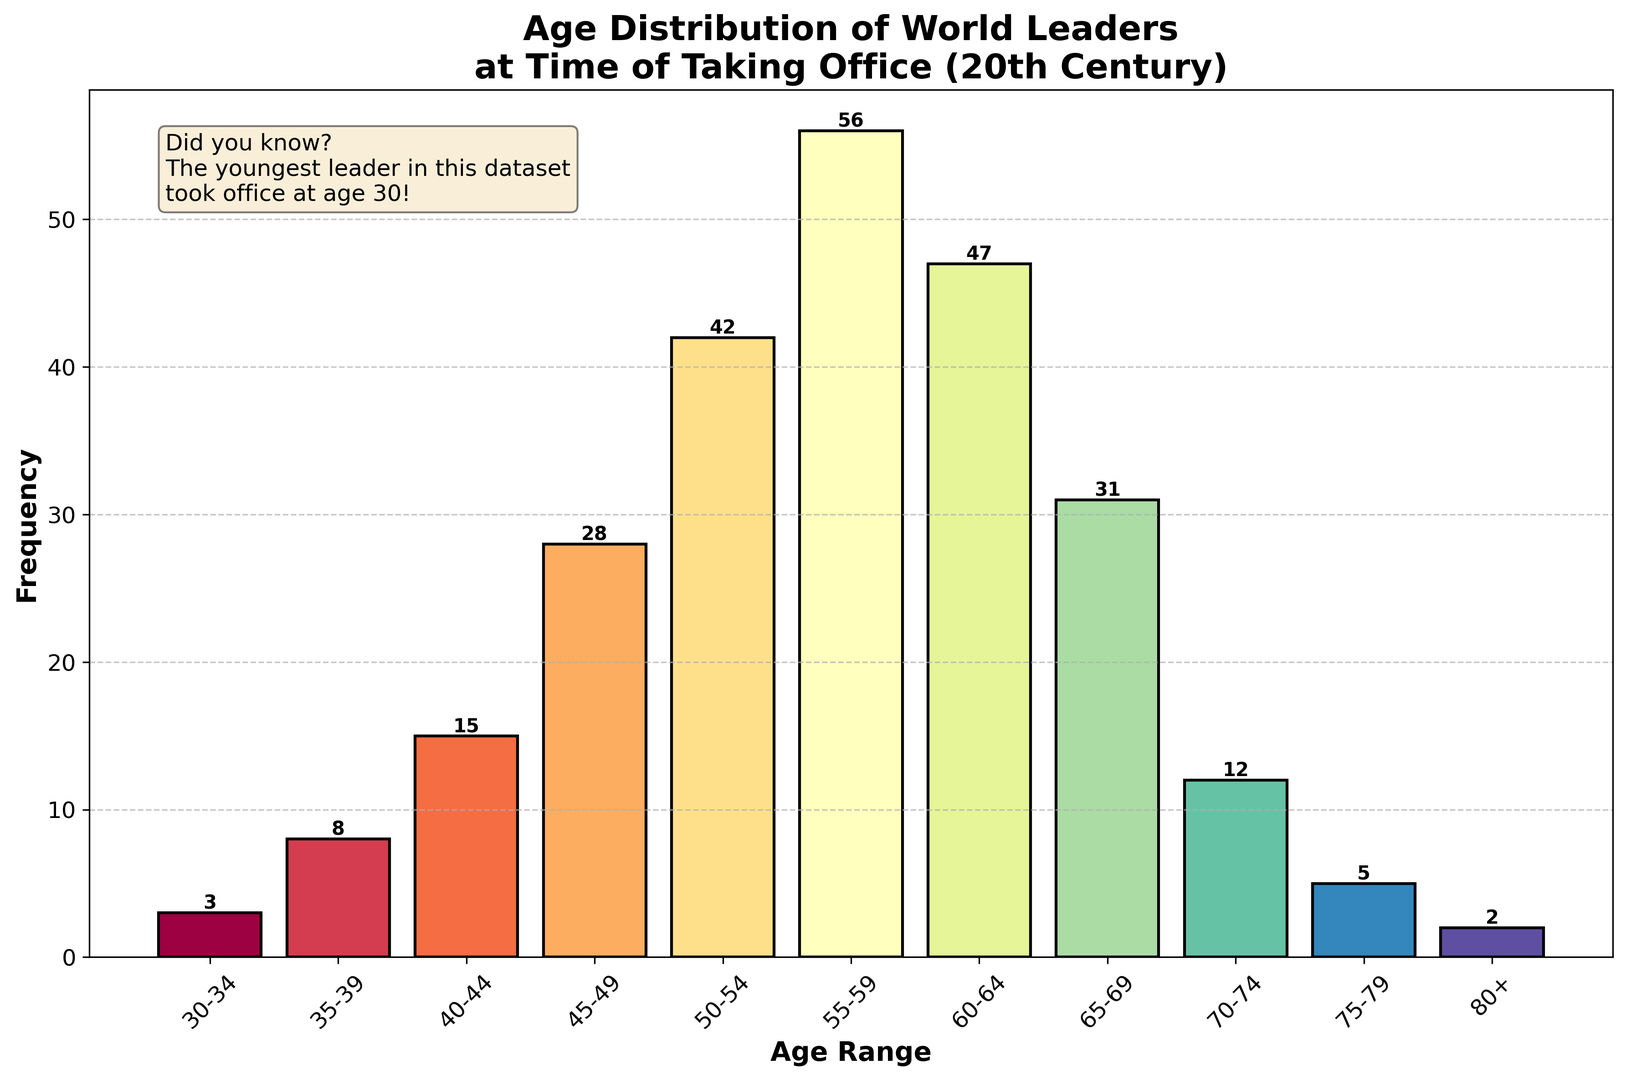What is the most common age range for world leaders at the time of taking office in the 20th century? From the plot, the tallest bar represents the most common age range. In this case, it's the "55-59" age range with a frequency of 56.
Answer: 55-59 How many world leaders took office at age 60 or older? Add the frequencies for the age ranges "60-64", "65-69", "70-74", "75-79", and "80+." The sum is 47 + 31 + 12 + 5 + 2 = 97.
Answer: 97 Which age range has the lowest number of world leaders taking office? The shortest bar represents the age range with the lowest number. It's the "80+" age range with a frequency of 2.
Answer: 80+ Are there more leaders in the "50-54" range or the "65-69" range, and by how much? Compare the frequencies of "50-54" (which is 42) and "65-69" (which is 31). The difference is 42 - 31 = 11.
Answer: 50-54, by 11 What is the total number of world leaders who took office in the age range between 35 and 54? Add the frequencies for the age ranges "35-39", "40-44", "45-49", and "50-54." The sum is 8 + 15 + 28 + 42 = 93.
Answer: 93 Which age range has a taller bar: "45-49" or "70-74"? Compare the heights of the bars for "45-49" and "70-74". "45-49" has a frequency of 28, and "70-74" has a frequency of 12. Therefore, "45-49" is taller.
Answer: 45-49 If we combine the frequencies of the age ranges below 50, what is the total count? Add the frequencies for the age ranges "30-34", "35-39", "40-44", and "45-49." The total is 3 + 8 + 15 + 28 = 54.
Answer: 54 Is the frequency of leaders in the "55-59" range higher, lower, or equal to the combined frequencies of "30-34" and "70-74"? Compare the frequency of "55-59" (56) to the combined frequencies of "30-34" and "70-74" (3 + 12 = 15). 56 is higher than 15.
Answer: Higher What is the difference in the number of leaders between the "50-54" range and the "60-64" range? Calculate the difference between the frequencies of "50-54" (42) and "60-64" (47). The difference is 47 - 42 = 5.
Answer: 5 